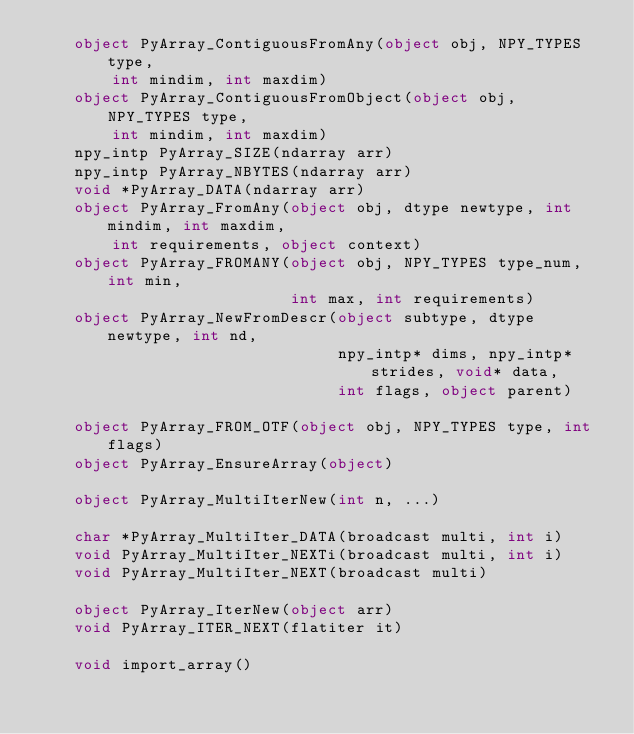<code> <loc_0><loc_0><loc_500><loc_500><_Cython_>    object PyArray_ContiguousFromAny(object obj, NPY_TYPES type, 
        int mindim, int maxdim)
    object PyArray_ContiguousFromObject(object obj, NPY_TYPES type, 
        int mindim, int maxdim)
    npy_intp PyArray_SIZE(ndarray arr)
    npy_intp PyArray_NBYTES(ndarray arr)
    void *PyArray_DATA(ndarray arr)
    object PyArray_FromAny(object obj, dtype newtype, int mindim, int maxdim,
		    int requirements, object context)
    object PyArray_FROMANY(object obj, NPY_TYPES type_num, int min,
                           int max, int requirements)
    object PyArray_NewFromDescr(object subtype, dtype newtype, int nd,
                                npy_intp* dims, npy_intp* strides, void* data,
                                int flags, object parent)

    object PyArray_FROM_OTF(object obj, NPY_TYPES type, int flags)
    object PyArray_EnsureArray(object)

    object PyArray_MultiIterNew(int n, ...)

    char *PyArray_MultiIter_DATA(broadcast multi, int i)
    void PyArray_MultiIter_NEXTi(broadcast multi, int i) 
    void PyArray_MultiIter_NEXT(broadcast multi)

    object PyArray_IterNew(object arr)
    void PyArray_ITER_NEXT(flatiter it)

    void import_array()
</code> 